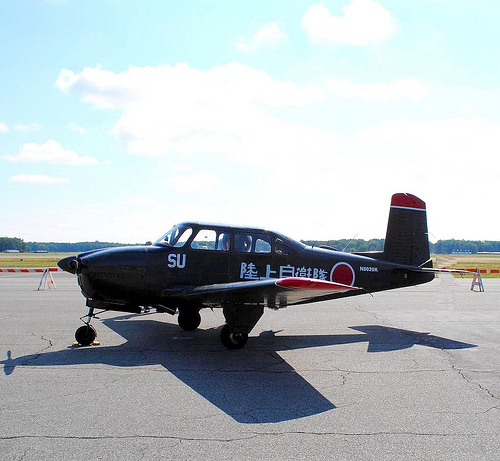Please provide a short description for this region: [0.43, 0.77, 0.6, 0.89]. The region depicts a shadow cast on the ground, likely by the plane or nearby objects, indicating the positioning and lighting conditions of the scene. 